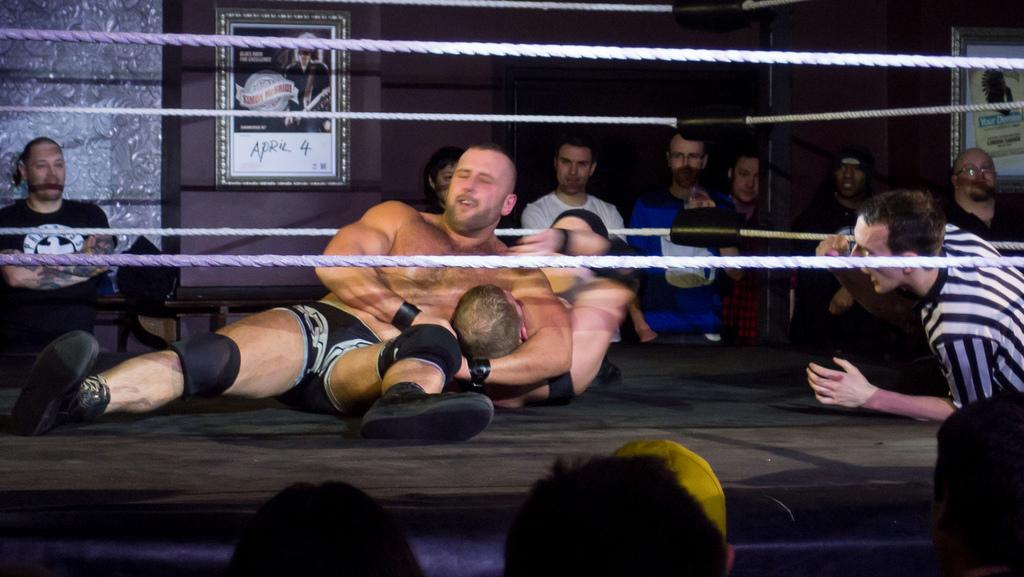What activity are the people in the image engaged in? The people in the image are wrestling. Are there any spectators in the image? Yes, there are people standing and watching the wrestling. What can be seen in the background of the image? There are frames attached to the wall in the background of the image. What type of plantation can be seen in the image? There is no plantation present in the image. What tool is being used by the wrestlers to gain an advantage? The image does not depict any tools being used by the wrestlers; it is a physical competition between two individuals. 